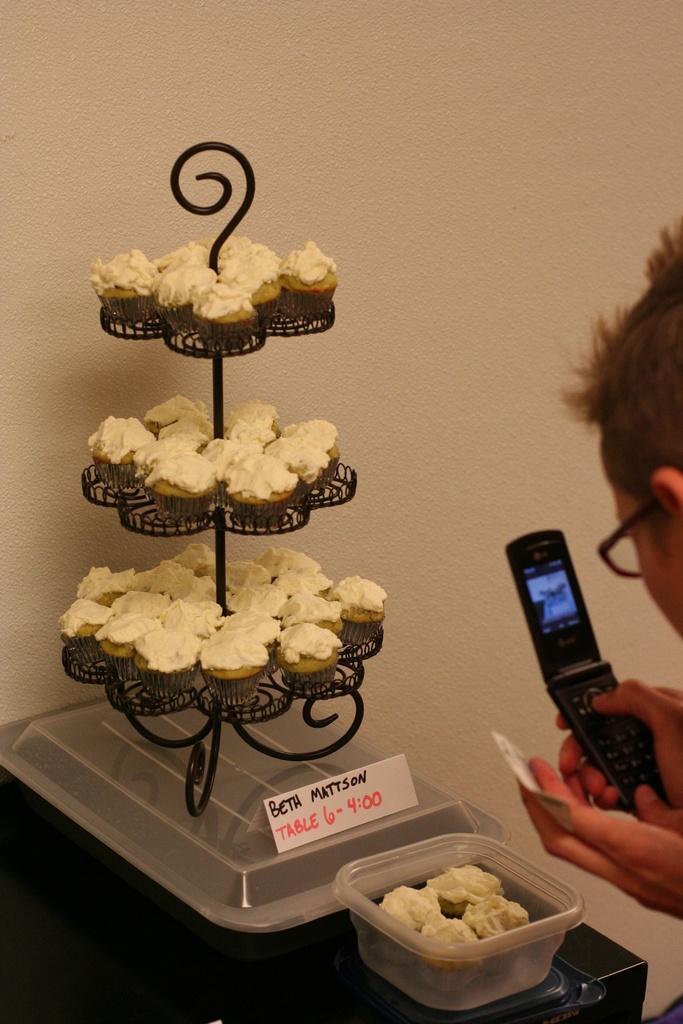In one or two sentences, can you explain what this image depicts? In this image we can see a person wearing spectacles is holding a mobile in his hand. In the left side of the image we can see several cupcakes placed in a stand and a container. 